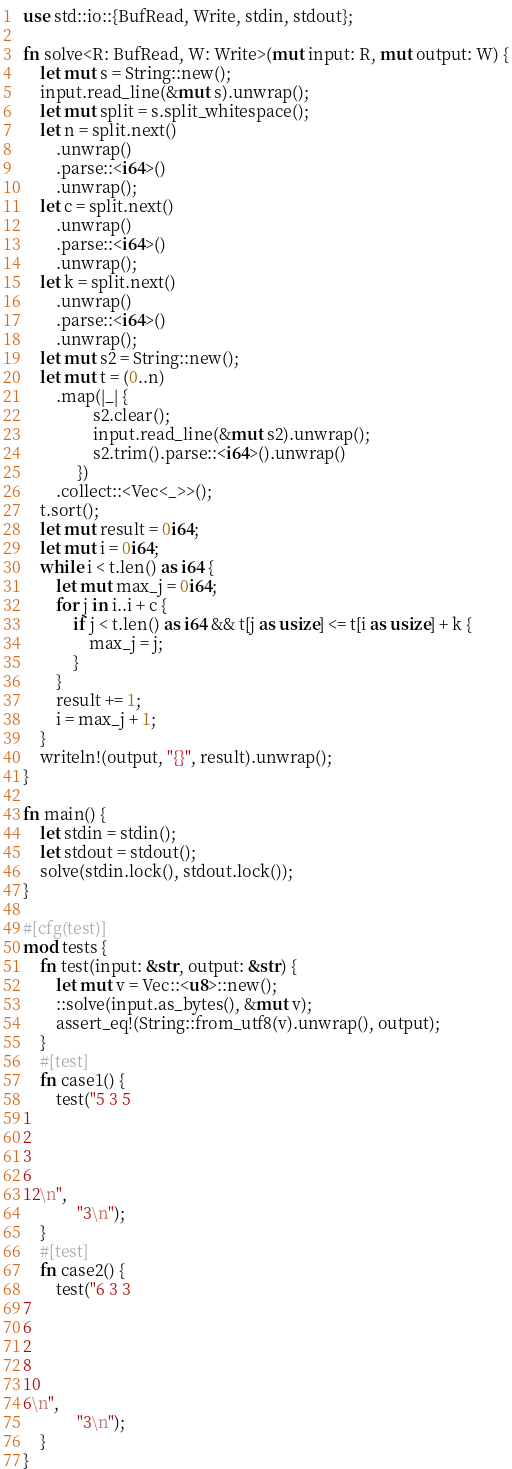<code> <loc_0><loc_0><loc_500><loc_500><_Rust_>use std::io::{BufRead, Write, stdin, stdout};

fn solve<R: BufRead, W: Write>(mut input: R, mut output: W) {
    let mut s = String::new();
    input.read_line(&mut s).unwrap();
    let mut split = s.split_whitespace();
    let n = split.next()
        .unwrap()
        .parse::<i64>()
        .unwrap();
    let c = split.next()
        .unwrap()
        .parse::<i64>()
        .unwrap();
    let k = split.next()
        .unwrap()
        .parse::<i64>()
        .unwrap();
    let mut s2 = String::new();
    let mut t = (0..n)
        .map(|_| {
                 s2.clear();
                 input.read_line(&mut s2).unwrap();
                 s2.trim().parse::<i64>().unwrap()
             })
        .collect::<Vec<_>>();
    t.sort();
    let mut result = 0i64;
    let mut i = 0i64;
    while i < t.len() as i64 {
        let mut max_j = 0i64;
        for j in i..i + c {
            if j < t.len() as i64 && t[j as usize] <= t[i as usize] + k {
                max_j = j;
            }
        }
        result += 1;
        i = max_j + 1;
    }
    writeln!(output, "{}", result).unwrap();
}

fn main() {
    let stdin = stdin();
    let stdout = stdout();
    solve(stdin.lock(), stdout.lock());
}

#[cfg(test)]
mod tests {
    fn test(input: &str, output: &str) {
        let mut v = Vec::<u8>::new();
        ::solve(input.as_bytes(), &mut v);
        assert_eq!(String::from_utf8(v).unwrap(), output);
    }
    #[test]
    fn case1() {
        test("5 3 5
1
2
3
6
12\n",
             "3\n");
    }
    #[test]
    fn case2() {
        test("6 3 3
7
6
2
8
10
6\n",
             "3\n");
    }
}
</code> 